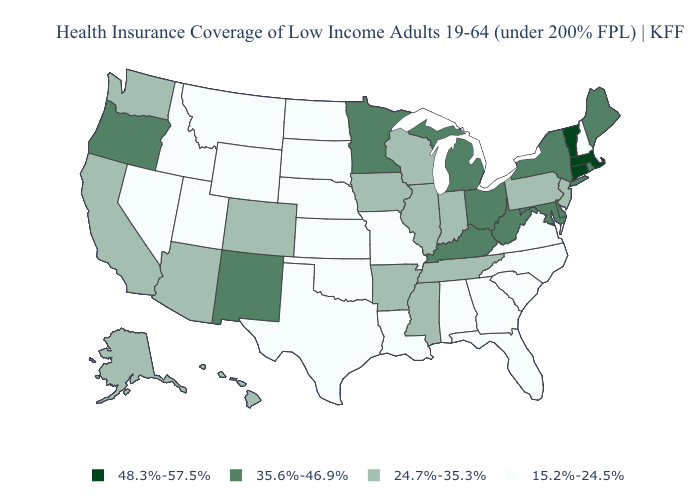How many symbols are there in the legend?
Be succinct. 4. Which states have the lowest value in the USA?
Short answer required. Alabama, Florida, Georgia, Idaho, Kansas, Louisiana, Missouri, Montana, Nebraska, Nevada, New Hampshire, North Carolina, North Dakota, Oklahoma, South Carolina, South Dakota, Texas, Utah, Virginia, Wyoming. Does Texas have the same value as Oregon?
Keep it brief. No. What is the highest value in states that border Oregon?
Be succinct. 24.7%-35.3%. Name the states that have a value in the range 48.3%-57.5%?
Write a very short answer. Connecticut, Massachusetts, Vermont. What is the value of Arizona?
Write a very short answer. 24.7%-35.3%. Name the states that have a value in the range 24.7%-35.3%?
Quick response, please. Alaska, Arizona, Arkansas, California, Colorado, Hawaii, Illinois, Indiana, Iowa, Mississippi, New Jersey, Pennsylvania, Tennessee, Washington, Wisconsin. Does Vermont have the highest value in the USA?
Give a very brief answer. Yes. What is the value of Michigan?
Quick response, please. 35.6%-46.9%. Among the states that border Rhode Island , which have the highest value?
Answer briefly. Connecticut, Massachusetts. What is the highest value in states that border Oklahoma?
Be succinct. 35.6%-46.9%. Does Tennessee have the same value as Oklahoma?
Give a very brief answer. No. What is the highest value in the West ?
Concise answer only. 35.6%-46.9%. What is the value of South Dakota?
Write a very short answer. 15.2%-24.5%. What is the lowest value in the USA?
Give a very brief answer. 15.2%-24.5%. 